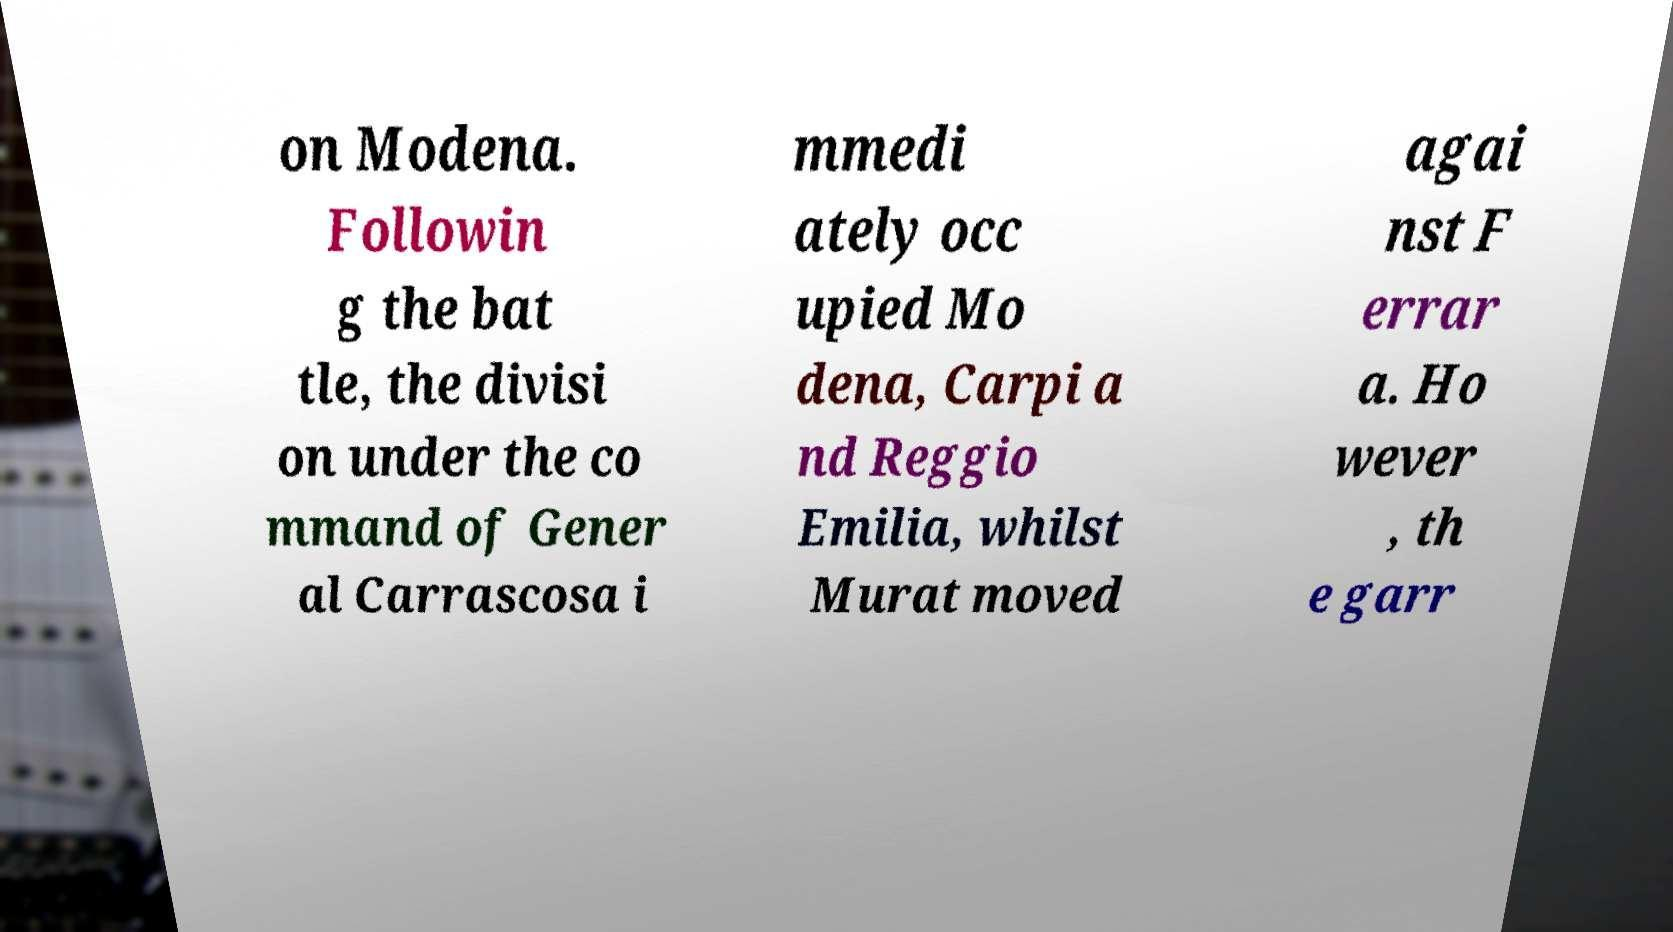I need the written content from this picture converted into text. Can you do that? on Modena. Followin g the bat tle, the divisi on under the co mmand of Gener al Carrascosa i mmedi ately occ upied Mo dena, Carpi a nd Reggio Emilia, whilst Murat moved agai nst F errar a. Ho wever , th e garr 